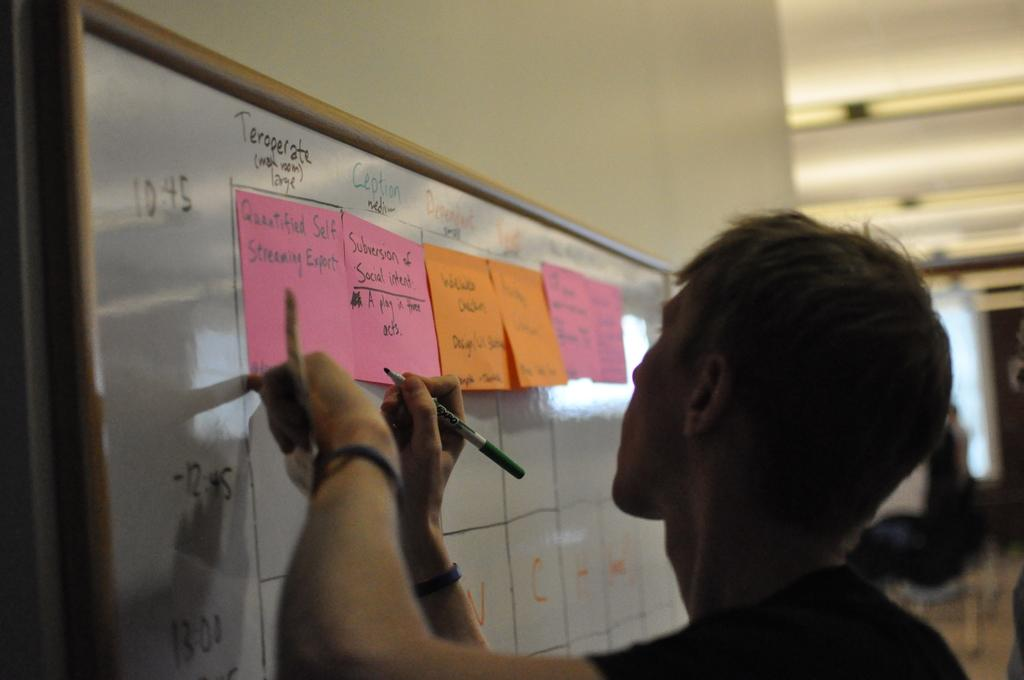<image>
Share a concise interpretation of the image provided. A man is prepared to write on a sticky-note labeled "Quantified Self Streaming Export." 